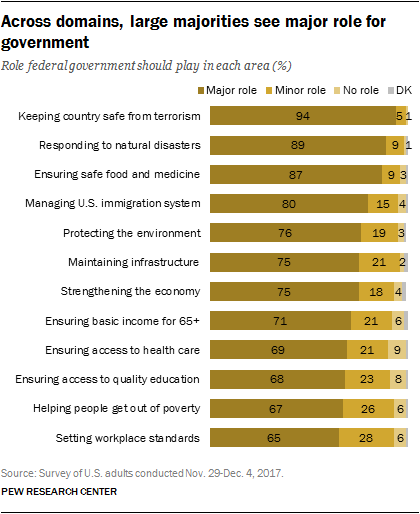Identify some key points in this picture. The government plays a crucial role in keeping a country safe from terrorism, with a ratio of 3.920138889... major to minor roles. According to a survey, 0.94% of respondents believe that the government's primary role is to keep the country safe from terrorism. 